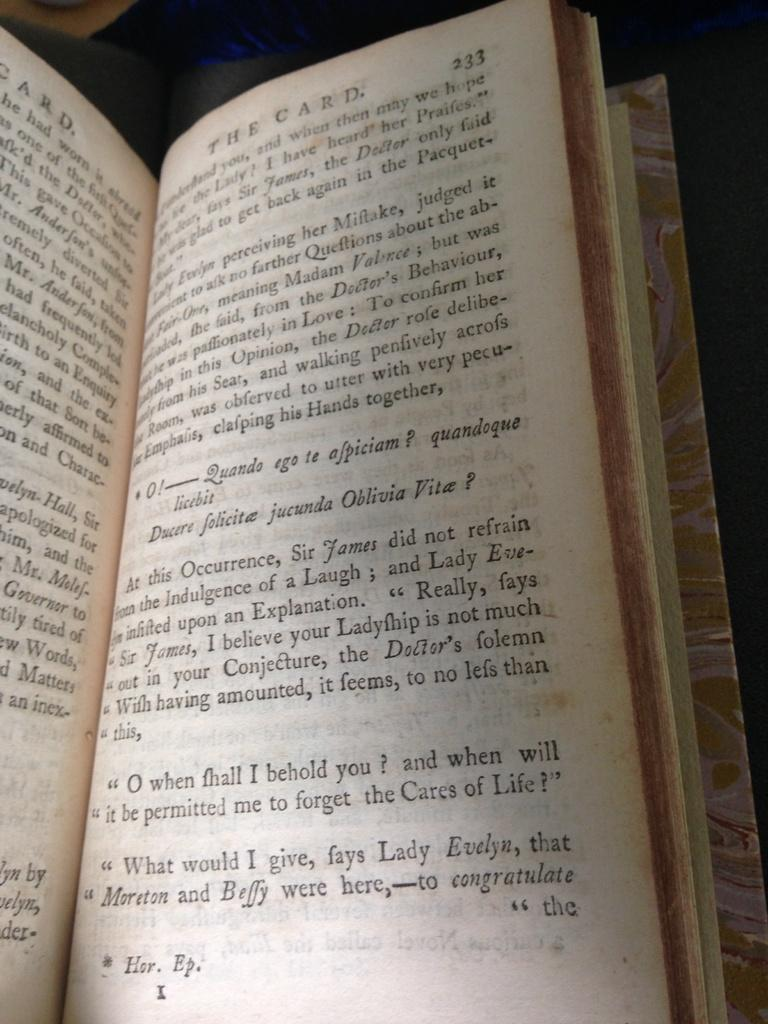Provide a one-sentence caption for the provided image. A book is open to page 233 and sits on a wooden surface. 